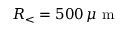<formula> <loc_0><loc_0><loc_500><loc_500>R _ { < } = 5 0 0 \, \mu m</formula> 